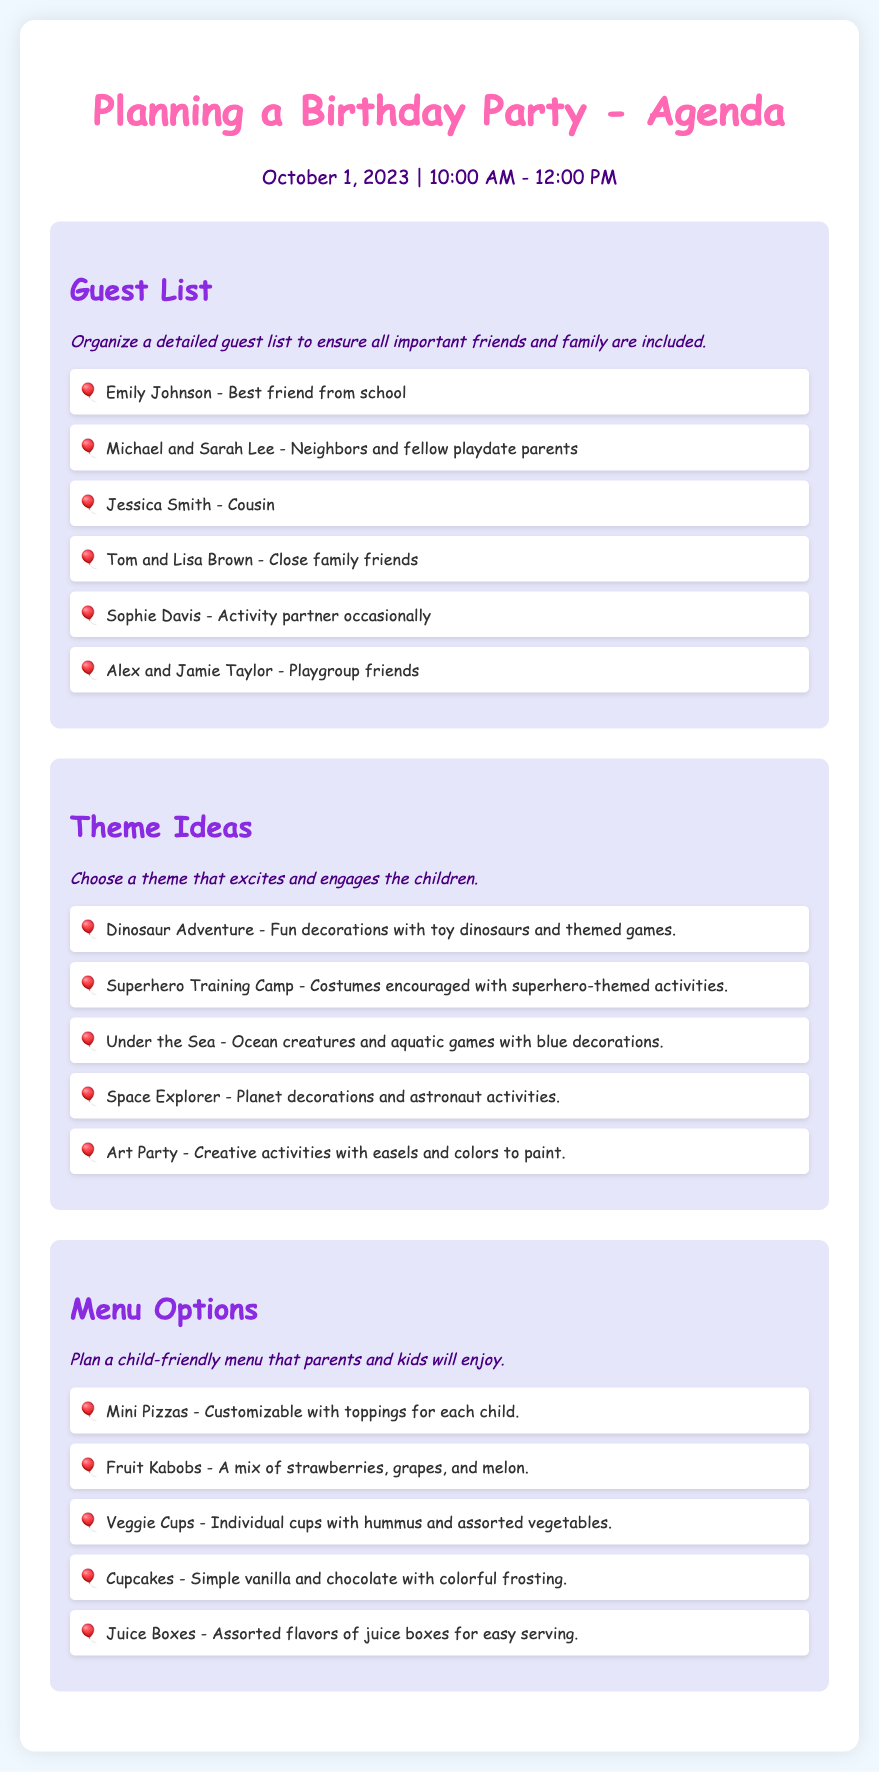Who is the best friend listed in the guest list? The guest list includes Emily Johnson, who is specifically mentioned as the best friend from school.
Answer: Emily Johnson What theme involves ocean creatures? The document lists the "Under the Sea" theme, which focuses on ocean creatures and aquatic games.
Answer: Under the Sea How many guests are listed in total? By counting the names presented in the guest list section, we see there are six individuals or families listed.
Answer: 6 Which menu item is described as customizable? The menu option that is customizable is the "Mini Pizzas," allowing children to choose their own toppings.
Answer: Mini Pizzas What is the color of the section titles? The section titles are consistently colored in a shade of purple mentioned as "#8a2be2."
Answer: Purple What type of party theme encourages costumes? The "Superhero Training Camp" theme encourages attendees to wear costumes related to superheroes.
Answer: Superhero Training Camp Which menu option includes both vanilla and chocolate? The menu option that includes both vanilla and chocolate flavors is the "Cupcakes."
Answer: Cupcakes 